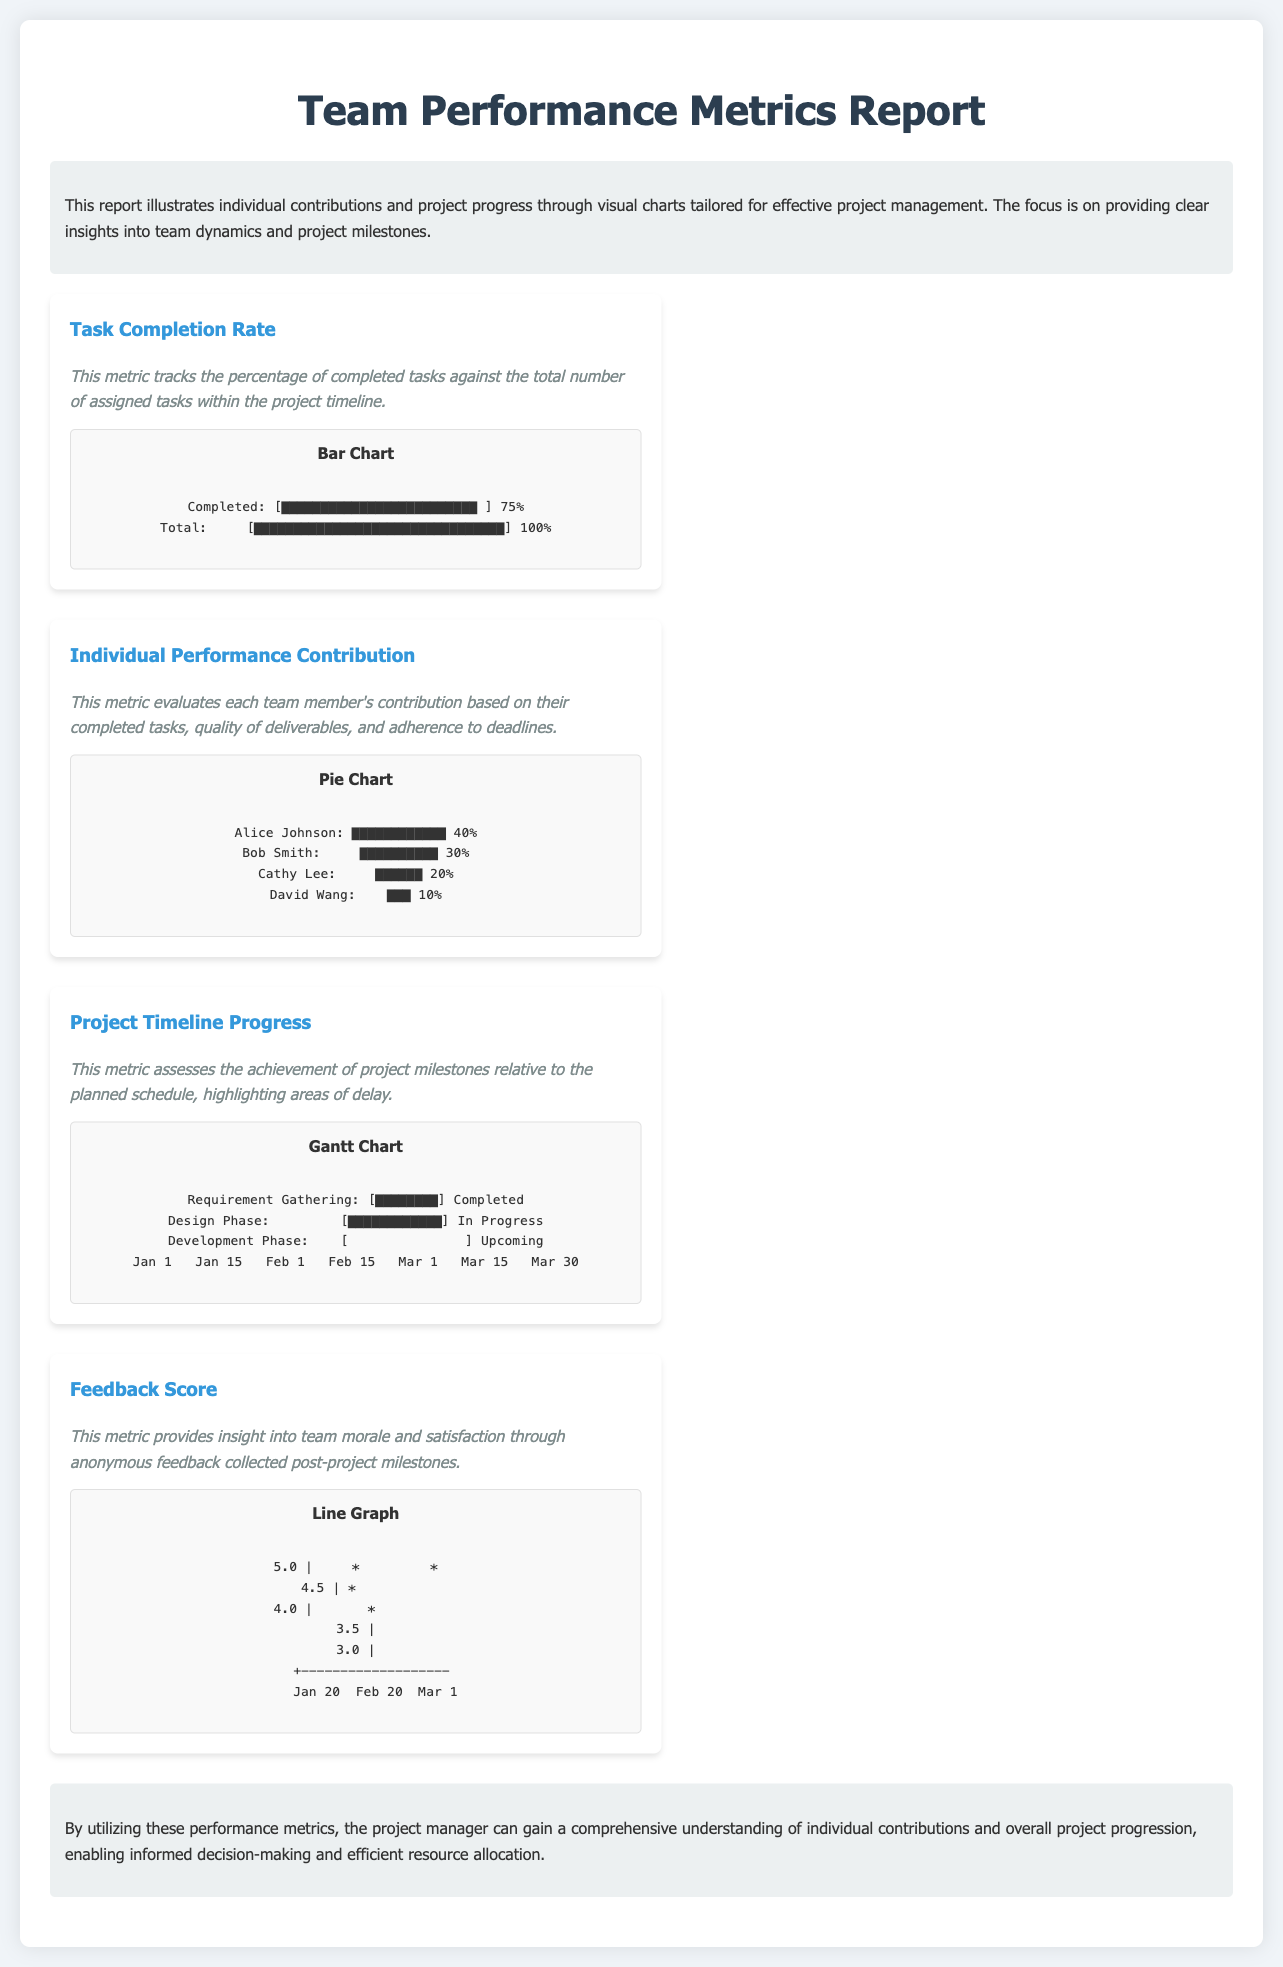What is the task completion rate? The task completion rate is indicated in the document, showing the percentage of completed tasks against the total assigned.
Answer: 75% Who contributed the most to the project? The individual performance contribution chart highlights the contributions of team members, with names and percentages listed.
Answer: Alice Johnson What is currently in progress according to the project timeline? The project timeline progress section lists the phases and their current status, indicating which phase is currently being worked on.
Answer: Design Phase What is the feedback score in the latest chart? The feedback score line graph shows the scores collected over time, with the most recent score plotted.
Answer: 5.0 How many tasks were completed out of the total assigned? The task completion bar chart illustrates completed versus total tasks visually, helping to identify the completion status.
Answer: 100% What phase will come after the design phase? The project timeline indicates the sequence of project phases and their statuses, showing which phases are upcoming.
Answer: Development Phase What is the percentage contribution of Bob Smith? The individual performance contribution chart specifically lists team member contributions in percentage terms, including Bob Smith's.
Answer: 30% What tool does the report suggest for understanding project dynamics? The document mentions utilizing performance metrics to gain insights into project management effectively.
Answer: Performance metrics 